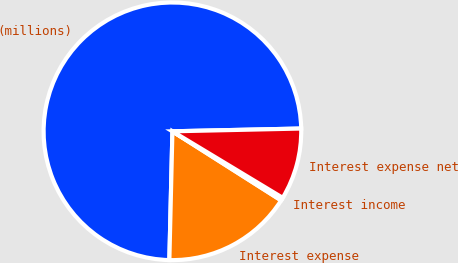<chart> <loc_0><loc_0><loc_500><loc_500><pie_chart><fcel>(millions)<fcel>Interest expense<fcel>Interest income<fcel>Interest expense net<nl><fcel>74.28%<fcel>16.37%<fcel>0.37%<fcel>8.98%<nl></chart> 